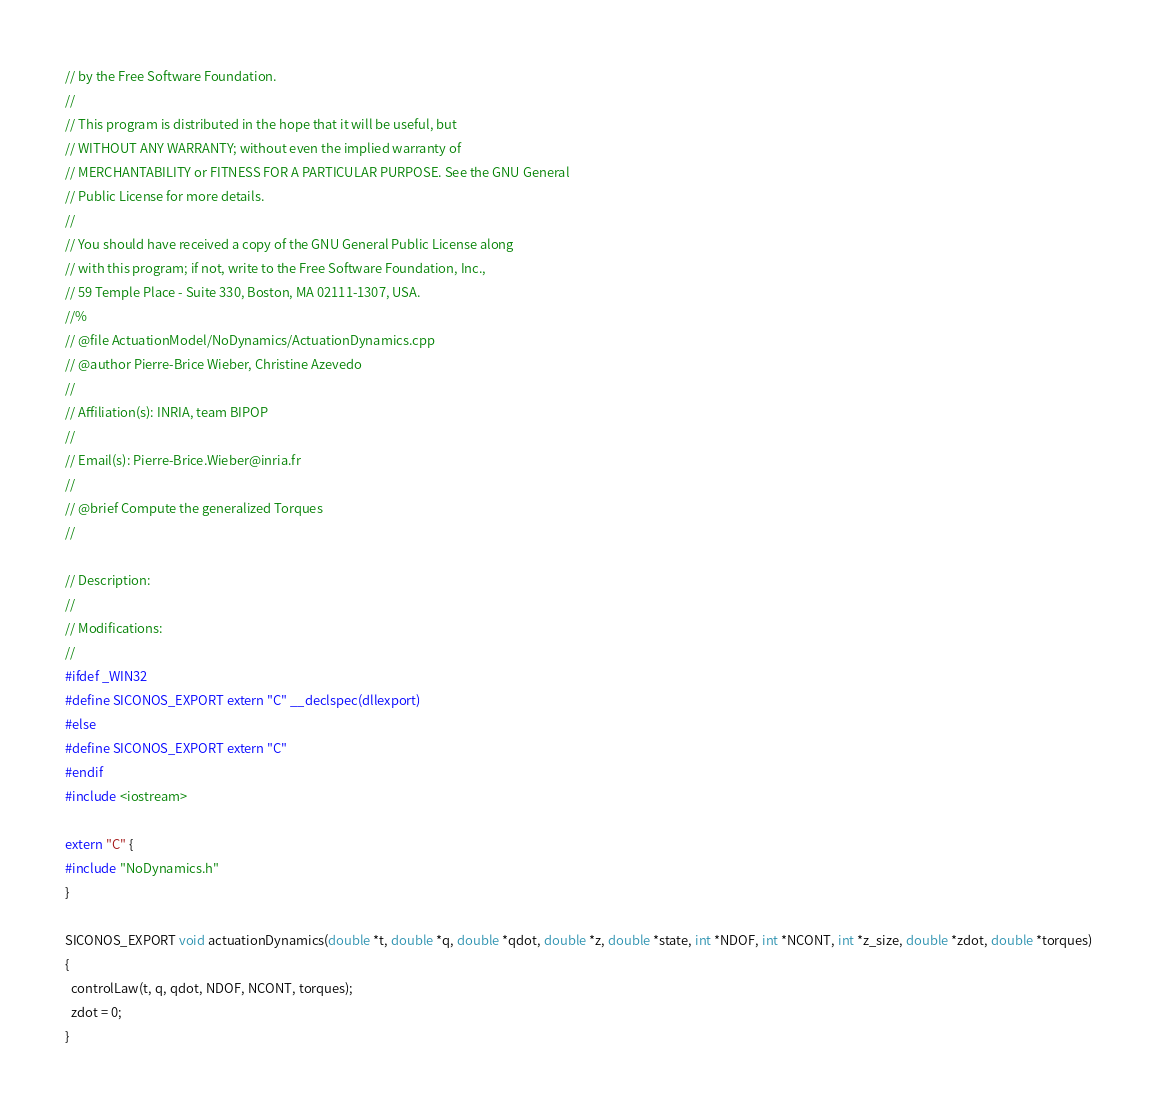Convert code to text. <code><loc_0><loc_0><loc_500><loc_500><_C++_>// by the Free Software Foundation.
//
// This program is distributed in the hope that it will be useful, but
// WITHOUT ANY WARRANTY; without even the implied warranty of
// MERCHANTABILITY or FITNESS FOR A PARTICULAR PURPOSE. See the GNU General
// Public License for more details.
//
// You should have received a copy of the GNU General Public License along
// with this program; if not, write to the Free Software Foundation, Inc.,
// 59 Temple Place - Suite 330, Boston, MA 02111-1307, USA.
//%
// @file ActuationModel/NoDynamics/ActuationDynamics.cpp
// @author Pierre-Brice Wieber, Christine Azevedo
//
// Affiliation(s): INRIA, team BIPOP
//
// Email(s): Pierre-Brice.Wieber@inria.fr
//
// @brief Compute the generalized Torques
//

// Description:
//
// Modifications:
//
#ifdef _WIN32 
#define SICONOS_EXPORT extern "C" __declspec(dllexport) 
#else 
#define SICONOS_EXPORT extern "C" 
#endif  
#include <iostream>

extern "C" {
#include "NoDynamics.h"
}

SICONOS_EXPORT void actuationDynamics(double *t, double *q, double *qdot, double *z, double *state, int *NDOF, int *NCONT, int *z_size, double *zdot, double *torques)
{
  controlLaw(t, q, qdot, NDOF, NCONT, torques);
  zdot = 0;
}
</code> 